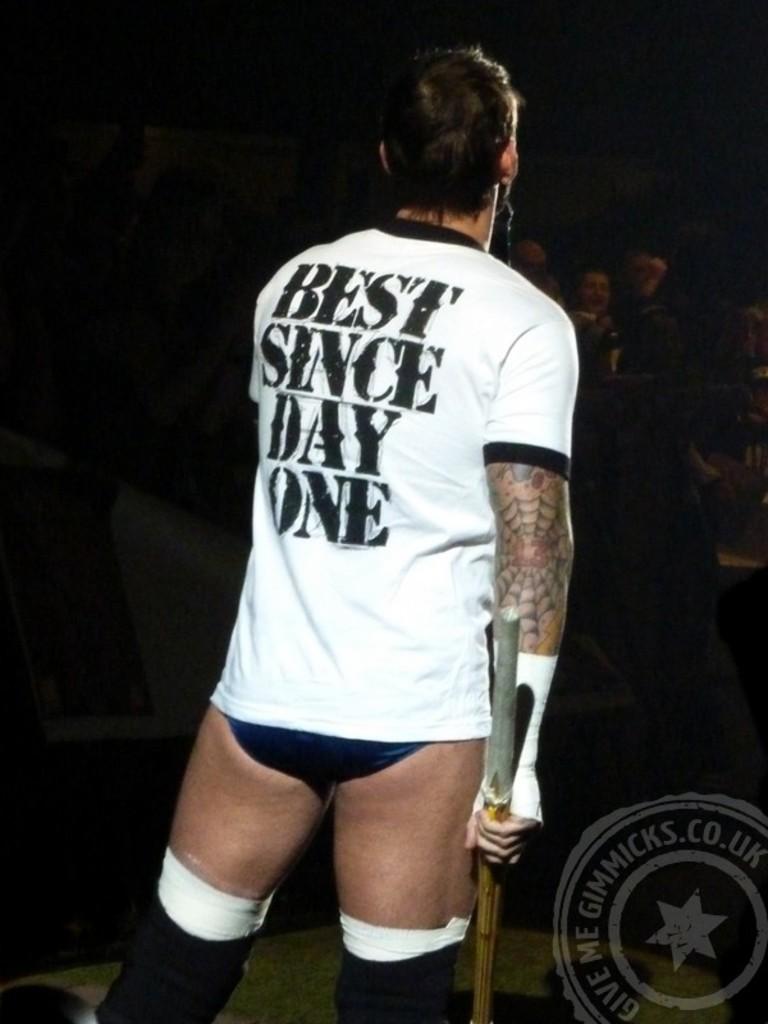Best since which day?
Your answer should be compact. One. What does the text say at the bottom in the circle?
Ensure brevity in your answer.  Give me gimmicks.co.uk. 